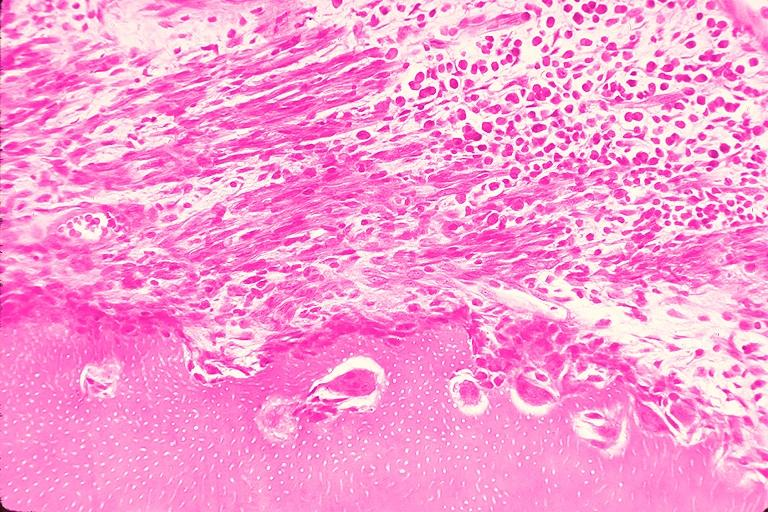s traumatic rupture present?
Answer the question using a single word or phrase. No 